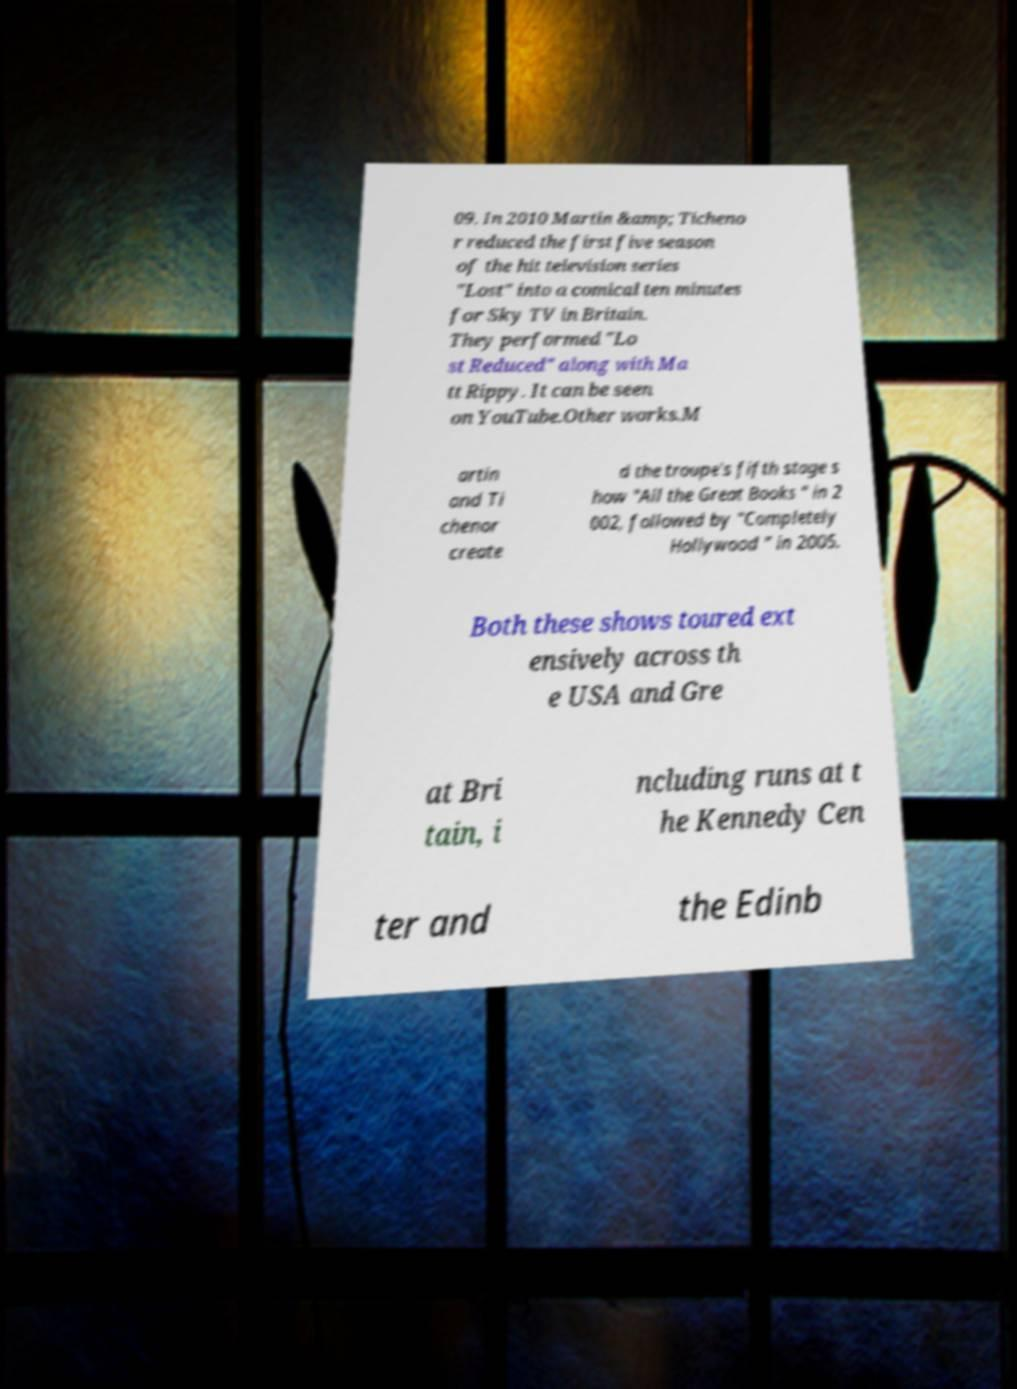Could you extract and type out the text from this image? 09. In 2010 Martin &amp; Ticheno r reduced the first five season of the hit television series "Lost" into a comical ten minutes for Sky TV in Britain. They performed "Lo st Reduced" along with Ma tt Rippy. It can be seen on YouTube.Other works.M artin and Ti chenor create d the troupe's fifth stage s how "All the Great Books " in 2 002, followed by "Completely Hollywood " in 2005. Both these shows toured ext ensively across th e USA and Gre at Bri tain, i ncluding runs at t he Kennedy Cen ter and the Edinb 